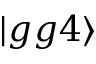<formula> <loc_0><loc_0><loc_500><loc_500>| g g 4 \rangle</formula> 